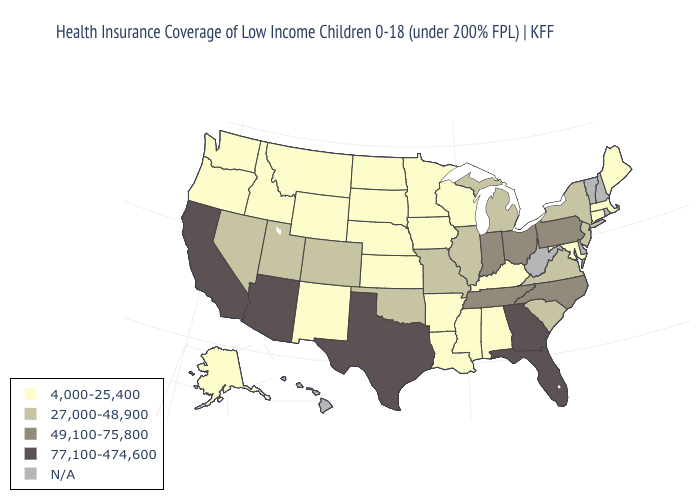What is the highest value in the USA?
Answer briefly. 77,100-474,600. What is the value of Colorado?
Answer briefly. 27,000-48,900. Does the map have missing data?
Quick response, please. Yes. What is the highest value in states that border New Hampshire?
Be succinct. 4,000-25,400. Does Florida have the lowest value in the USA?
Answer briefly. No. What is the value of New Mexico?
Give a very brief answer. 4,000-25,400. What is the value of Hawaii?
Keep it brief. N/A. Among the states that border Wyoming , does South Dakota have the lowest value?
Concise answer only. Yes. What is the value of Georgia?
Give a very brief answer. 77,100-474,600. Among the states that border Maryland , does Virginia have the lowest value?
Write a very short answer. Yes. What is the highest value in the South ?
Write a very short answer. 77,100-474,600. Which states have the highest value in the USA?
Give a very brief answer. Arizona, California, Florida, Georgia, Texas. Does the first symbol in the legend represent the smallest category?
Be succinct. Yes. Name the states that have a value in the range 49,100-75,800?
Keep it brief. Indiana, North Carolina, Ohio, Pennsylvania, Tennessee. 